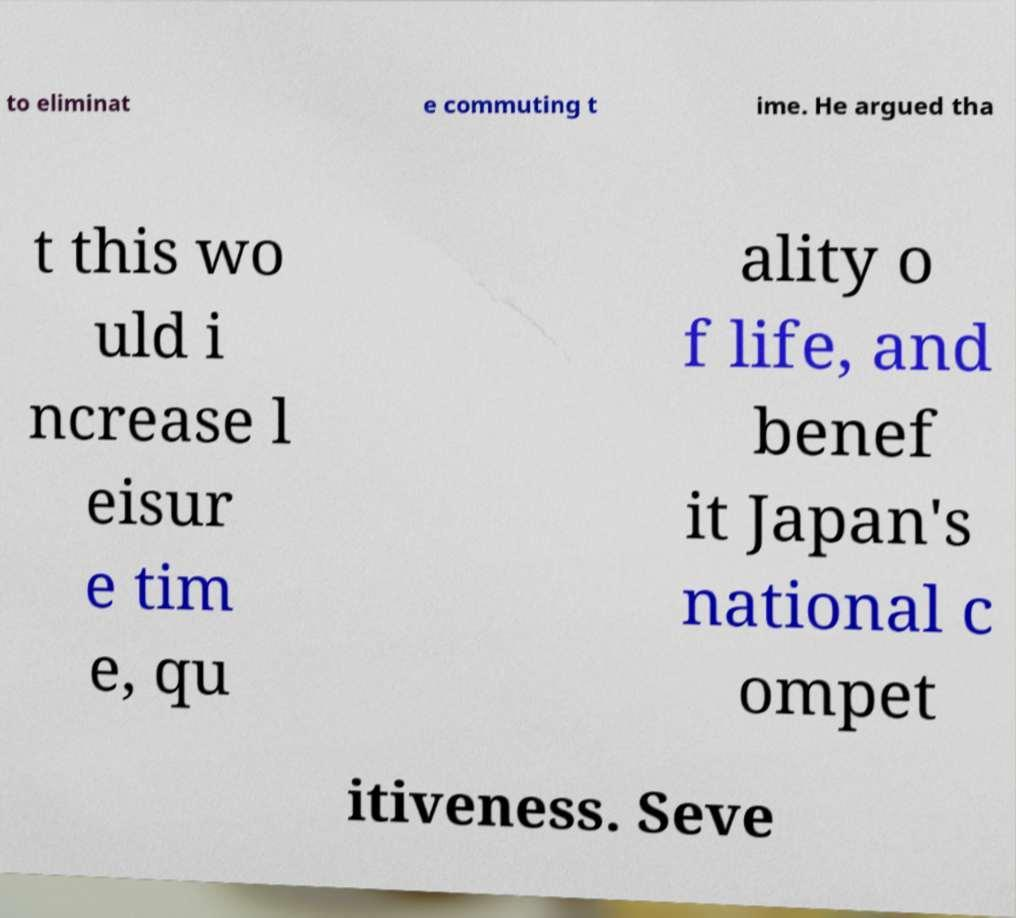Please identify and transcribe the text found in this image. to eliminat e commuting t ime. He argued tha t this wo uld i ncrease l eisur e tim e, qu ality o f life, and benef it Japan's national c ompet itiveness. Seve 